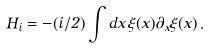Convert formula to latex. <formula><loc_0><loc_0><loc_500><loc_500>H _ { i } = - ( i / 2 ) \int d x \, \xi ( x ) \partial _ { x } \xi ( x ) \, .</formula> 